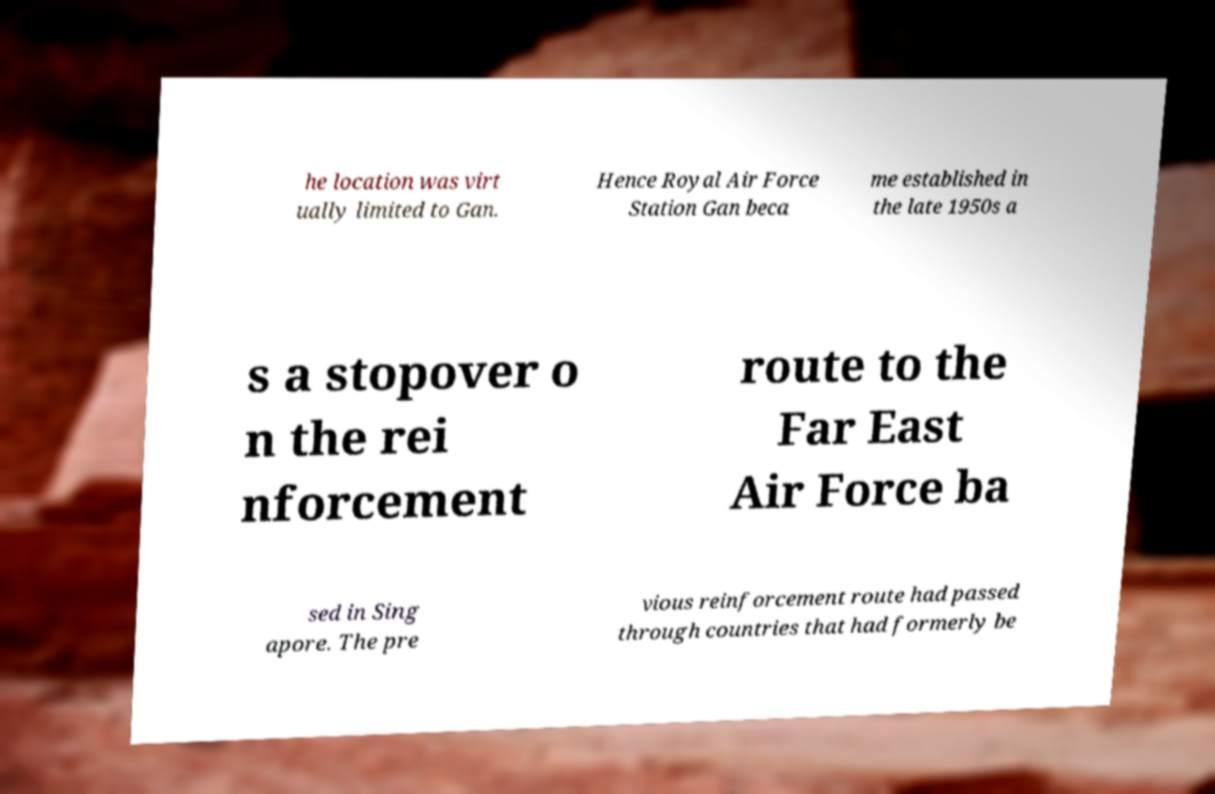There's text embedded in this image that I need extracted. Can you transcribe it verbatim? he location was virt ually limited to Gan. Hence Royal Air Force Station Gan beca me established in the late 1950s a s a stopover o n the rei nforcement route to the Far East Air Force ba sed in Sing apore. The pre vious reinforcement route had passed through countries that had formerly be 